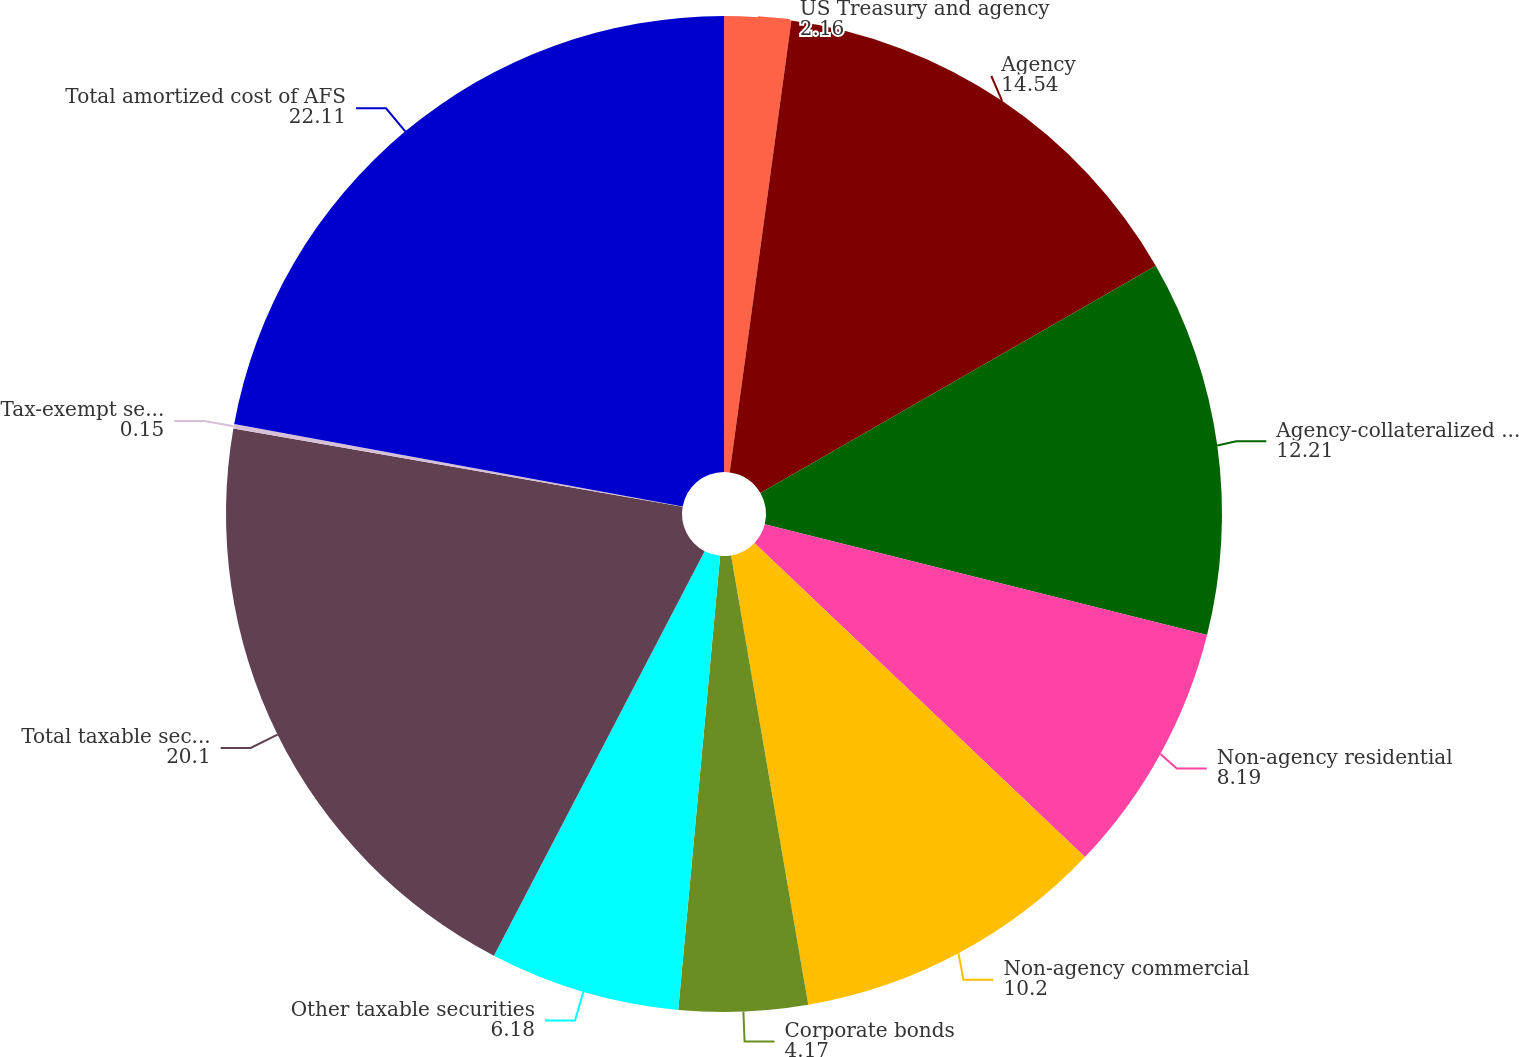Convert chart. <chart><loc_0><loc_0><loc_500><loc_500><pie_chart><fcel>US Treasury and agency<fcel>Agency<fcel>Agency-collateralized mortgage<fcel>Non-agency residential<fcel>Non-agency commercial<fcel>Corporate bonds<fcel>Other taxable securities<fcel>Total taxable securities<fcel>Tax-exempt securities<fcel>Total amortized cost of AFS<nl><fcel>2.16%<fcel>14.54%<fcel>12.21%<fcel>8.19%<fcel>10.2%<fcel>4.17%<fcel>6.18%<fcel>20.1%<fcel>0.15%<fcel>22.11%<nl></chart> 